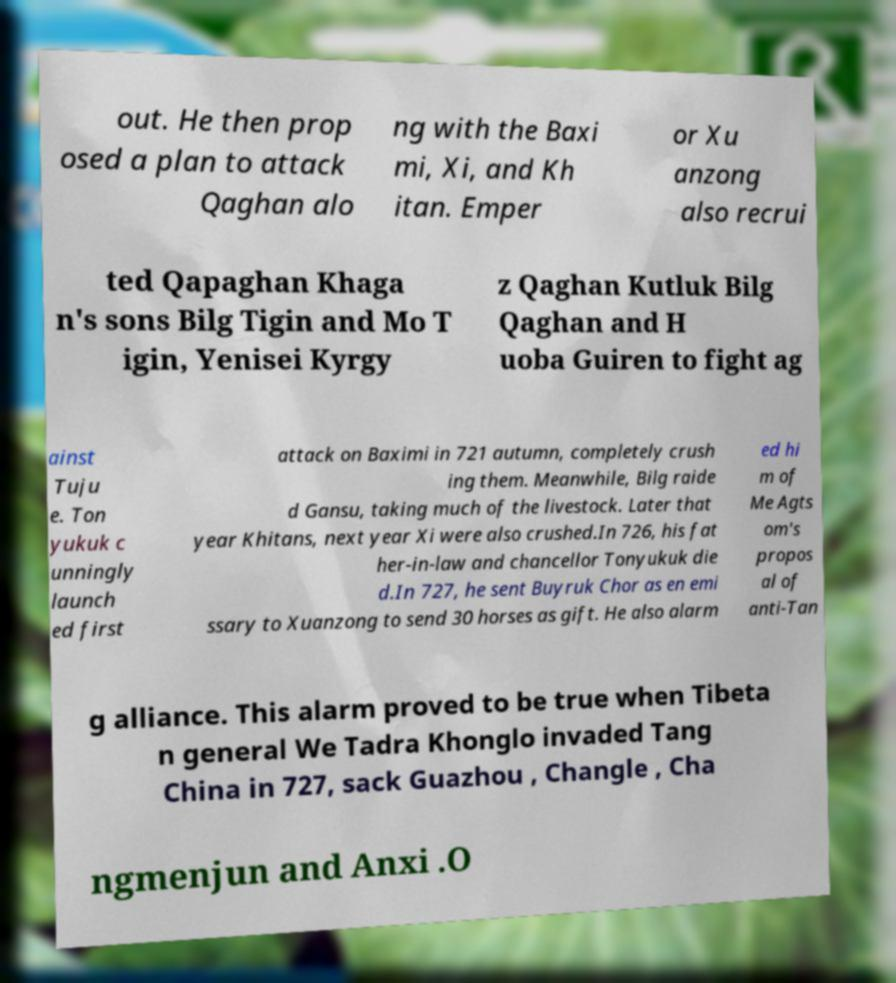Can you read and provide the text displayed in the image?This photo seems to have some interesting text. Can you extract and type it out for me? out. He then prop osed a plan to attack Qaghan alo ng with the Baxi mi, Xi, and Kh itan. Emper or Xu anzong also recrui ted Qapaghan Khaga n's sons Bilg Tigin and Mo T igin, Yenisei Kyrgy z Qaghan Kutluk Bilg Qaghan and H uoba Guiren to fight ag ainst Tuju e. Ton yukuk c unningly launch ed first attack on Baximi in 721 autumn, completely crush ing them. Meanwhile, Bilg raide d Gansu, taking much of the livestock. Later that year Khitans, next year Xi were also crushed.In 726, his fat her-in-law and chancellor Tonyukuk die d.In 727, he sent Buyruk Chor as en emi ssary to Xuanzong to send 30 horses as gift. He also alarm ed hi m of Me Agts om's propos al of anti-Tan g alliance. This alarm proved to be true when Tibeta n general We Tadra Khonglo invaded Tang China in 727, sack Guazhou , Changle , Cha ngmenjun and Anxi .O 